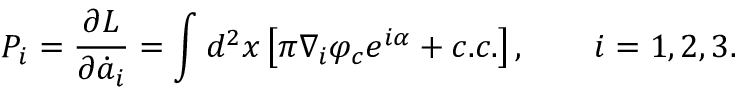Convert formula to latex. <formula><loc_0><loc_0><loc_500><loc_500>P _ { i } = \frac { \partial L } { \partial \dot { a } _ { i } } = \int d ^ { 2 } x \left [ \pi \nabla _ { i } \varphi _ { c } e ^ { i \alpha } + c . c . \right ] , \quad i = 1 , 2 , 3 .</formula> 